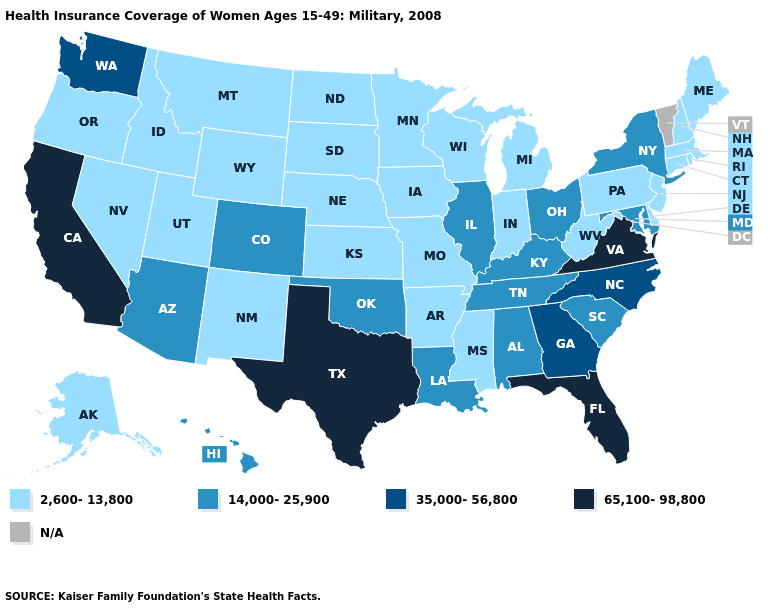Name the states that have a value in the range 65,100-98,800?
Answer briefly. California, Florida, Texas, Virginia. Name the states that have a value in the range 14,000-25,900?
Write a very short answer. Alabama, Arizona, Colorado, Hawaii, Illinois, Kentucky, Louisiana, Maryland, New York, Ohio, Oklahoma, South Carolina, Tennessee. Name the states that have a value in the range N/A?
Be succinct. Vermont. What is the value of Arkansas?
Give a very brief answer. 2,600-13,800. Name the states that have a value in the range 2,600-13,800?
Be succinct. Alaska, Arkansas, Connecticut, Delaware, Idaho, Indiana, Iowa, Kansas, Maine, Massachusetts, Michigan, Minnesota, Mississippi, Missouri, Montana, Nebraska, Nevada, New Hampshire, New Jersey, New Mexico, North Dakota, Oregon, Pennsylvania, Rhode Island, South Dakota, Utah, West Virginia, Wisconsin, Wyoming. What is the value of Alaska?
Give a very brief answer. 2,600-13,800. Which states have the lowest value in the South?
Short answer required. Arkansas, Delaware, Mississippi, West Virginia. What is the lowest value in the MidWest?
Keep it brief. 2,600-13,800. What is the value of Tennessee?
Quick response, please. 14,000-25,900. Does West Virginia have the highest value in the USA?
Concise answer only. No. Does Louisiana have the highest value in the South?
Short answer required. No. Name the states that have a value in the range 65,100-98,800?
Quick response, please. California, Florida, Texas, Virginia. What is the value of Virginia?
Short answer required. 65,100-98,800. What is the value of Colorado?
Concise answer only. 14,000-25,900. 